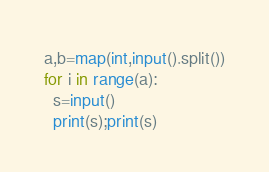Convert code to text. <code><loc_0><loc_0><loc_500><loc_500><_Python_>a,b=map(int,input().split())
for i in range(a):
  s=input()
  print(s);print(s)</code> 